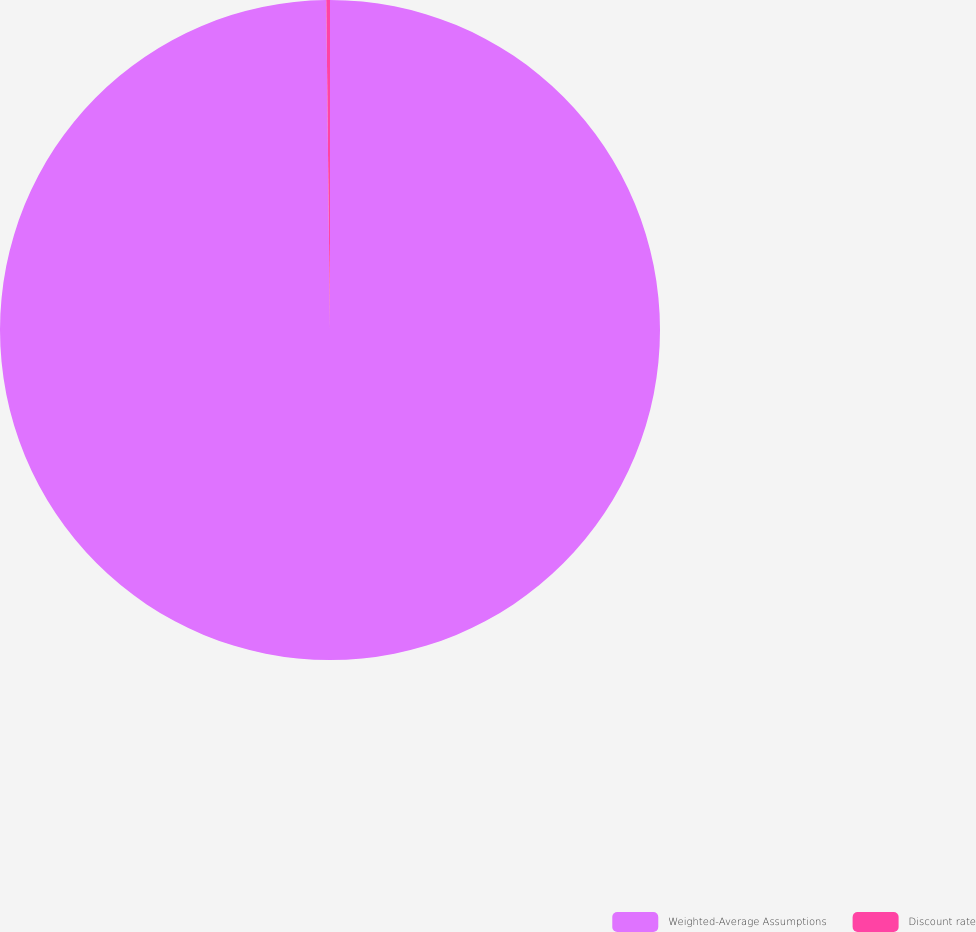<chart> <loc_0><loc_0><loc_500><loc_500><pie_chart><fcel>Weighted-Average Assumptions<fcel>Discount rate<nl><fcel>99.82%<fcel>0.18%<nl></chart> 